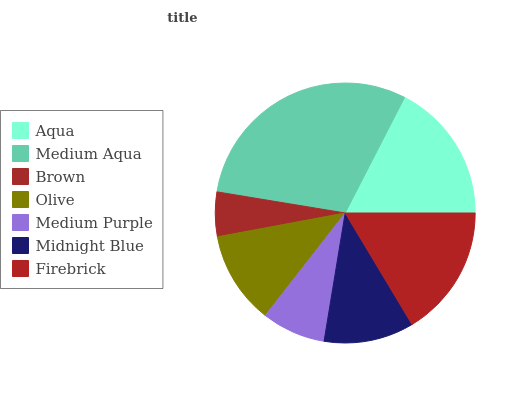Is Brown the minimum?
Answer yes or no. Yes. Is Medium Aqua the maximum?
Answer yes or no. Yes. Is Medium Aqua the minimum?
Answer yes or no. No. Is Brown the maximum?
Answer yes or no. No. Is Medium Aqua greater than Brown?
Answer yes or no. Yes. Is Brown less than Medium Aqua?
Answer yes or no. Yes. Is Brown greater than Medium Aqua?
Answer yes or no. No. Is Medium Aqua less than Brown?
Answer yes or no. No. Is Olive the high median?
Answer yes or no. Yes. Is Olive the low median?
Answer yes or no. Yes. Is Brown the high median?
Answer yes or no. No. Is Brown the low median?
Answer yes or no. No. 